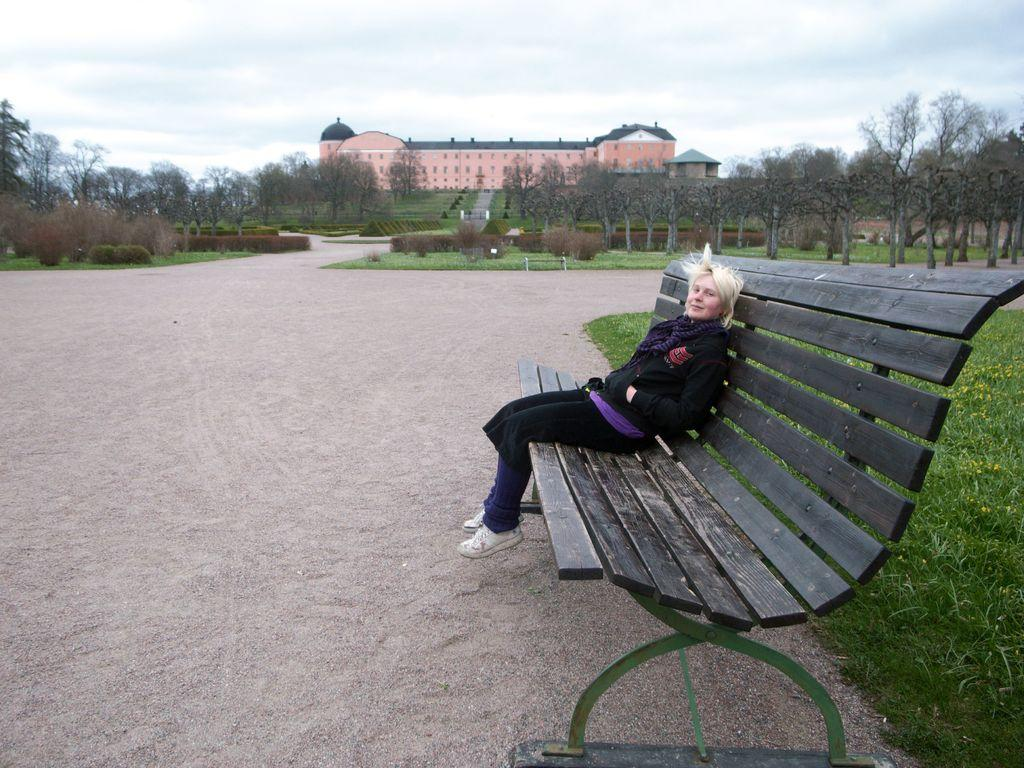What is the woman doing in the image? The woman is sitting on a wooden table in the image. What can be seen in the distance behind the woman? There is a house and trees in the background of the image. What is visible above the house and trees? The sky is visible in the background of the image. What can be observed in the sky? Clouds are present in the sky. What type of drum can be heard playing in the image? There is no drum or any sound present in the image; it is a still image. 